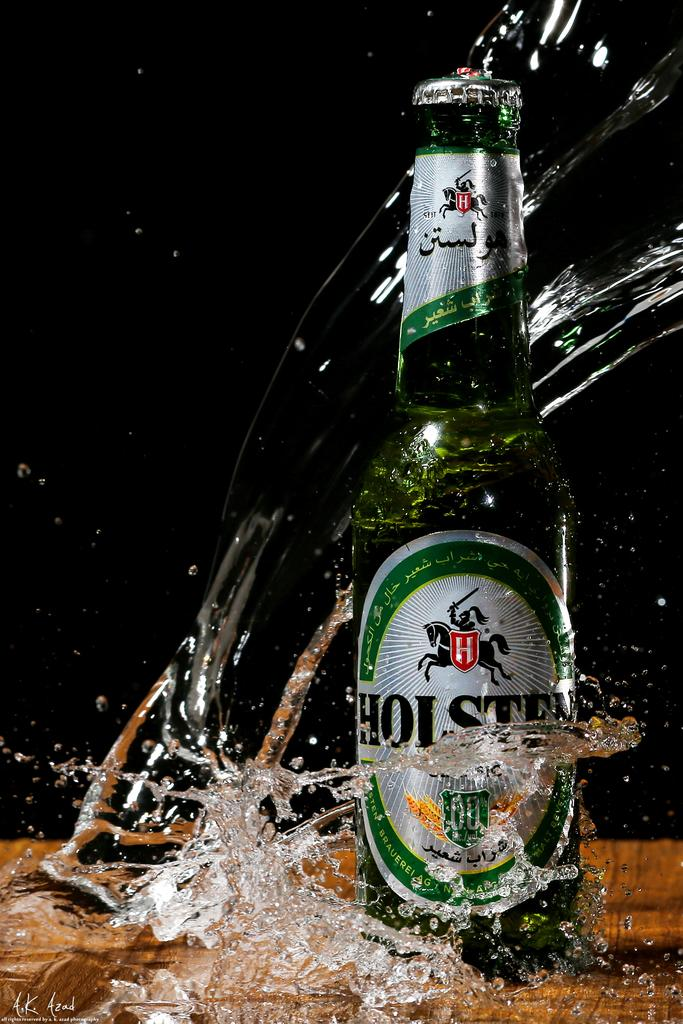What object can be seen in the image? There is a bottle in the image. Where is the bottle located? The bottle is on a surface. What is visible inside the bottle? Water is visible in the image. Can you describe the background of the image? The background of the image is blurred. How many stones are present in the image? There are no stones visible in the image. What type of spiders can be seen crawling on the bottle? There are no spiders present in the image. 